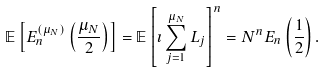<formula> <loc_0><loc_0><loc_500><loc_500>\mathbb { E } \left [ E _ { n } ^ { ( \mu _ { N } ) } \left ( \frac { \mu _ { N } } { 2 } \right ) \right ] = \mathbb { E } \left [ \imath \sum _ { j = 1 } ^ { \mu _ { N } } L _ { j } \right ] ^ { n } = N ^ { n } E _ { n } \left ( \frac { 1 } { 2 } \right ) .</formula> 